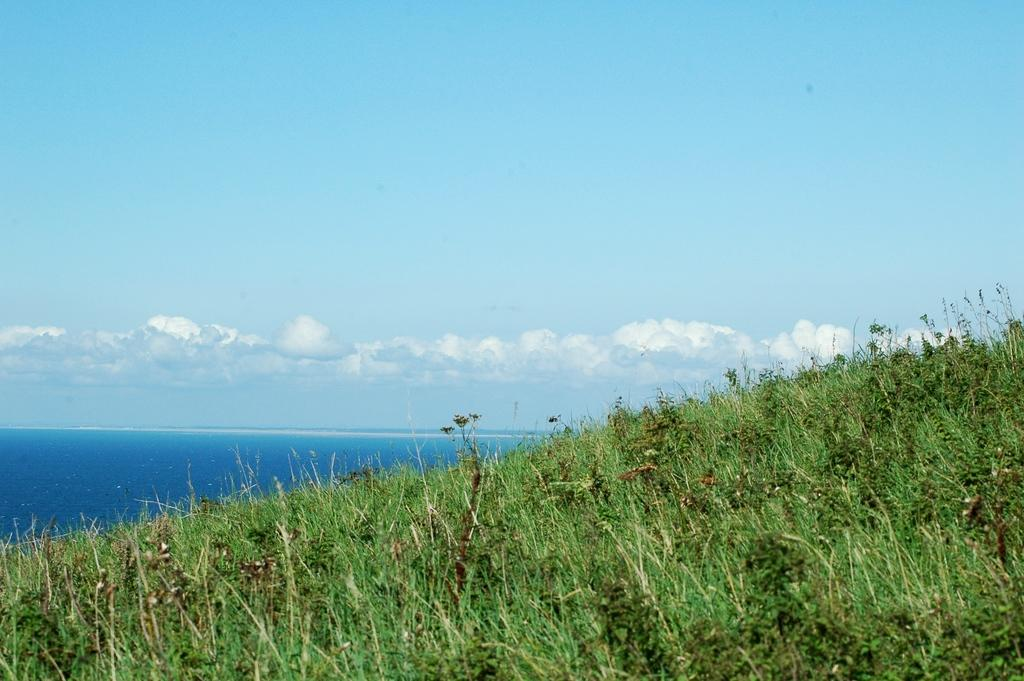What type of vegetation can be seen in the image? There are trees in the image. What is the color of the trees? The trees are green in color. What can be seen in the background of the image? There is water and the sky visible in the background of the image. How many boys are smiling in the image? There are no boys or smiles present in the image; it features trees, water, and the sky. 